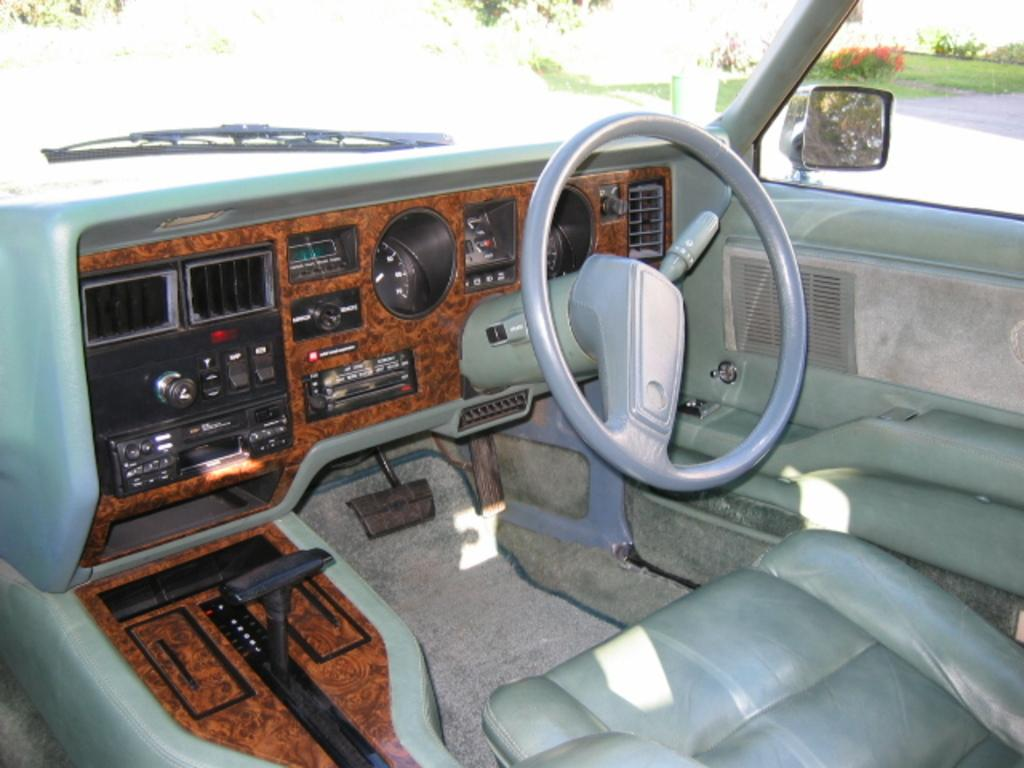What is the setting of the image? The image shows the inside view of a car. What is a prominent feature of the car's interior? There is a steering wheel in the car. What is provided for passengers to sit in the car? There are seats in the car. What can be seen in the background of the image? There are trees and flowers in the background of the image. Can you tell me how many seeds are visible in the image? There are no seeds present in the image. Who is the creator of the car in the image? The image does not provide information about the creator of the car. 